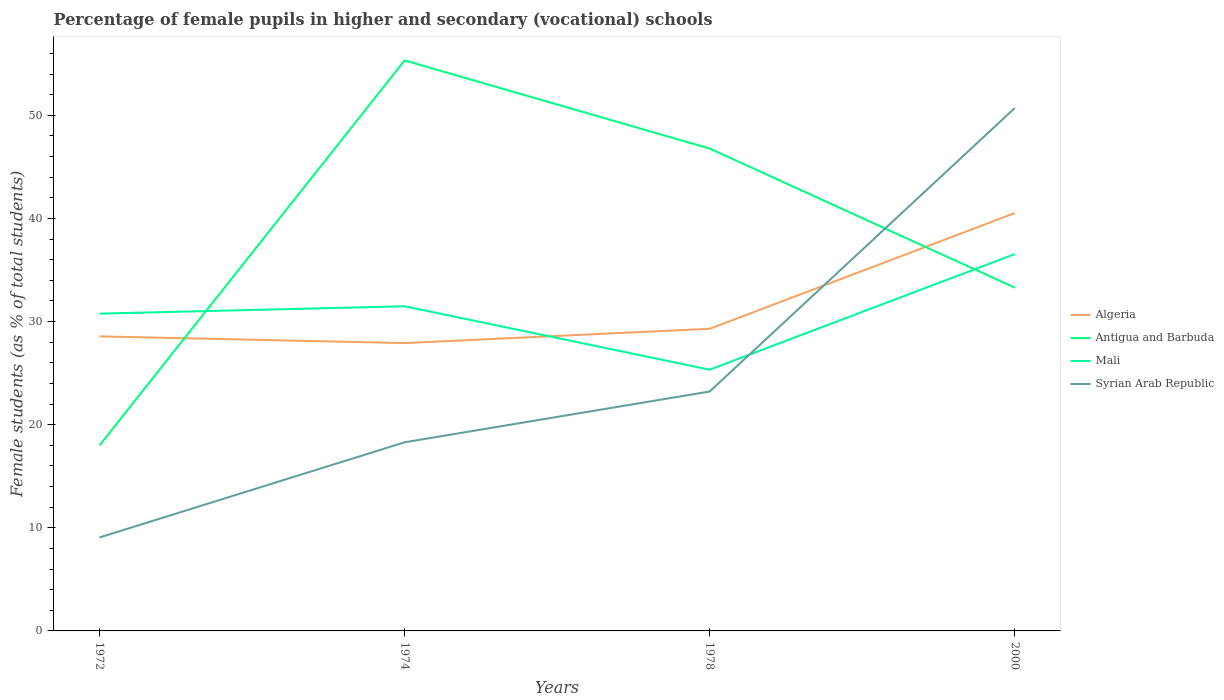Is the number of lines equal to the number of legend labels?
Your answer should be compact. Yes. Across all years, what is the maximum percentage of female pupils in higher and secondary schools in Syrian Arab Republic?
Ensure brevity in your answer.  9.06. In which year was the percentage of female pupils in higher and secondary schools in Syrian Arab Republic maximum?
Offer a very short reply. 1972. What is the total percentage of female pupils in higher and secondary schools in Mali in the graph?
Make the answer very short. -0.71. What is the difference between the highest and the second highest percentage of female pupils in higher and secondary schools in Antigua and Barbuda?
Provide a short and direct response. 37.33. Is the percentage of female pupils in higher and secondary schools in Syrian Arab Republic strictly greater than the percentage of female pupils in higher and secondary schools in Antigua and Barbuda over the years?
Ensure brevity in your answer.  No. How many lines are there?
Ensure brevity in your answer.  4. Where does the legend appear in the graph?
Make the answer very short. Center right. How many legend labels are there?
Make the answer very short. 4. What is the title of the graph?
Ensure brevity in your answer.  Percentage of female pupils in higher and secondary (vocational) schools. What is the label or title of the Y-axis?
Offer a very short reply. Female students (as % of total students). What is the Female students (as % of total students) in Algeria in 1972?
Keep it short and to the point. 28.56. What is the Female students (as % of total students) of Antigua and Barbuda in 1972?
Your answer should be compact. 17.99. What is the Female students (as % of total students) in Mali in 1972?
Your answer should be compact. 30.77. What is the Female students (as % of total students) of Syrian Arab Republic in 1972?
Your answer should be compact. 9.06. What is the Female students (as % of total students) in Algeria in 1974?
Give a very brief answer. 27.91. What is the Female students (as % of total students) in Antigua and Barbuda in 1974?
Your answer should be compact. 55.32. What is the Female students (as % of total students) in Mali in 1974?
Offer a terse response. 31.48. What is the Female students (as % of total students) in Syrian Arab Republic in 1974?
Your answer should be very brief. 18.29. What is the Female students (as % of total students) of Algeria in 1978?
Your answer should be compact. 29.3. What is the Female students (as % of total students) in Antigua and Barbuda in 1978?
Ensure brevity in your answer.  46.77. What is the Female students (as % of total students) of Mali in 1978?
Offer a very short reply. 25.33. What is the Female students (as % of total students) of Syrian Arab Republic in 1978?
Provide a short and direct response. 23.21. What is the Female students (as % of total students) in Algeria in 2000?
Make the answer very short. 40.52. What is the Female students (as % of total students) in Antigua and Barbuda in 2000?
Provide a succinct answer. 33.29. What is the Female students (as % of total students) of Mali in 2000?
Provide a succinct answer. 36.54. What is the Female students (as % of total students) of Syrian Arab Republic in 2000?
Your answer should be very brief. 50.7. Across all years, what is the maximum Female students (as % of total students) of Algeria?
Provide a succinct answer. 40.52. Across all years, what is the maximum Female students (as % of total students) of Antigua and Barbuda?
Your answer should be compact. 55.32. Across all years, what is the maximum Female students (as % of total students) of Mali?
Provide a succinct answer. 36.54. Across all years, what is the maximum Female students (as % of total students) in Syrian Arab Republic?
Provide a succinct answer. 50.7. Across all years, what is the minimum Female students (as % of total students) in Algeria?
Offer a very short reply. 27.91. Across all years, what is the minimum Female students (as % of total students) of Antigua and Barbuda?
Ensure brevity in your answer.  17.99. Across all years, what is the minimum Female students (as % of total students) of Mali?
Provide a succinct answer. 25.33. Across all years, what is the minimum Female students (as % of total students) in Syrian Arab Republic?
Provide a succinct answer. 9.06. What is the total Female students (as % of total students) of Algeria in the graph?
Provide a short and direct response. 126.29. What is the total Female students (as % of total students) in Antigua and Barbuda in the graph?
Provide a short and direct response. 153.37. What is the total Female students (as % of total students) in Mali in the graph?
Make the answer very short. 124.12. What is the total Female students (as % of total students) of Syrian Arab Republic in the graph?
Your answer should be very brief. 101.27. What is the difference between the Female students (as % of total students) in Algeria in 1972 and that in 1974?
Ensure brevity in your answer.  0.65. What is the difference between the Female students (as % of total students) of Antigua and Barbuda in 1972 and that in 1974?
Keep it short and to the point. -37.33. What is the difference between the Female students (as % of total students) in Mali in 1972 and that in 1974?
Your answer should be compact. -0.71. What is the difference between the Female students (as % of total students) in Syrian Arab Republic in 1972 and that in 1974?
Keep it short and to the point. -9.23. What is the difference between the Female students (as % of total students) of Algeria in 1972 and that in 1978?
Your answer should be compact. -0.73. What is the difference between the Female students (as % of total students) of Antigua and Barbuda in 1972 and that in 1978?
Your response must be concise. -28.78. What is the difference between the Female students (as % of total students) in Mali in 1972 and that in 1978?
Offer a very short reply. 5.43. What is the difference between the Female students (as % of total students) in Syrian Arab Republic in 1972 and that in 1978?
Keep it short and to the point. -14.15. What is the difference between the Female students (as % of total students) in Algeria in 1972 and that in 2000?
Keep it short and to the point. -11.96. What is the difference between the Female students (as % of total students) in Antigua and Barbuda in 1972 and that in 2000?
Your answer should be very brief. -15.29. What is the difference between the Female students (as % of total students) in Mali in 1972 and that in 2000?
Provide a succinct answer. -5.77. What is the difference between the Female students (as % of total students) in Syrian Arab Republic in 1972 and that in 2000?
Your answer should be compact. -41.64. What is the difference between the Female students (as % of total students) in Algeria in 1974 and that in 1978?
Provide a short and direct response. -1.38. What is the difference between the Female students (as % of total students) in Antigua and Barbuda in 1974 and that in 1978?
Provide a succinct answer. 8.54. What is the difference between the Female students (as % of total students) of Mali in 1974 and that in 1978?
Your answer should be very brief. 6.15. What is the difference between the Female students (as % of total students) of Syrian Arab Republic in 1974 and that in 1978?
Your answer should be compact. -4.92. What is the difference between the Female students (as % of total students) of Algeria in 1974 and that in 2000?
Provide a succinct answer. -12.61. What is the difference between the Female students (as % of total students) of Antigua and Barbuda in 1974 and that in 2000?
Keep it short and to the point. 22.03. What is the difference between the Female students (as % of total students) of Mali in 1974 and that in 2000?
Give a very brief answer. -5.06. What is the difference between the Female students (as % of total students) in Syrian Arab Republic in 1974 and that in 2000?
Make the answer very short. -32.41. What is the difference between the Female students (as % of total students) in Algeria in 1978 and that in 2000?
Offer a terse response. -11.22. What is the difference between the Female students (as % of total students) of Antigua and Barbuda in 1978 and that in 2000?
Your answer should be very brief. 13.49. What is the difference between the Female students (as % of total students) of Mali in 1978 and that in 2000?
Make the answer very short. -11.21. What is the difference between the Female students (as % of total students) in Syrian Arab Republic in 1978 and that in 2000?
Ensure brevity in your answer.  -27.49. What is the difference between the Female students (as % of total students) in Algeria in 1972 and the Female students (as % of total students) in Antigua and Barbuda in 1974?
Provide a short and direct response. -26.76. What is the difference between the Female students (as % of total students) of Algeria in 1972 and the Female students (as % of total students) of Mali in 1974?
Give a very brief answer. -2.92. What is the difference between the Female students (as % of total students) in Algeria in 1972 and the Female students (as % of total students) in Syrian Arab Republic in 1974?
Make the answer very short. 10.27. What is the difference between the Female students (as % of total students) in Antigua and Barbuda in 1972 and the Female students (as % of total students) in Mali in 1974?
Your answer should be very brief. -13.49. What is the difference between the Female students (as % of total students) of Antigua and Barbuda in 1972 and the Female students (as % of total students) of Syrian Arab Republic in 1974?
Provide a succinct answer. -0.3. What is the difference between the Female students (as % of total students) in Mali in 1972 and the Female students (as % of total students) in Syrian Arab Republic in 1974?
Make the answer very short. 12.48. What is the difference between the Female students (as % of total students) in Algeria in 1972 and the Female students (as % of total students) in Antigua and Barbuda in 1978?
Your answer should be compact. -18.21. What is the difference between the Female students (as % of total students) in Algeria in 1972 and the Female students (as % of total students) in Mali in 1978?
Your answer should be very brief. 3.23. What is the difference between the Female students (as % of total students) of Algeria in 1972 and the Female students (as % of total students) of Syrian Arab Republic in 1978?
Keep it short and to the point. 5.35. What is the difference between the Female students (as % of total students) of Antigua and Barbuda in 1972 and the Female students (as % of total students) of Mali in 1978?
Give a very brief answer. -7.34. What is the difference between the Female students (as % of total students) of Antigua and Barbuda in 1972 and the Female students (as % of total students) of Syrian Arab Republic in 1978?
Offer a terse response. -5.22. What is the difference between the Female students (as % of total students) of Mali in 1972 and the Female students (as % of total students) of Syrian Arab Republic in 1978?
Provide a succinct answer. 7.55. What is the difference between the Female students (as % of total students) of Algeria in 1972 and the Female students (as % of total students) of Antigua and Barbuda in 2000?
Offer a terse response. -4.72. What is the difference between the Female students (as % of total students) of Algeria in 1972 and the Female students (as % of total students) of Mali in 2000?
Make the answer very short. -7.98. What is the difference between the Female students (as % of total students) of Algeria in 1972 and the Female students (as % of total students) of Syrian Arab Republic in 2000?
Keep it short and to the point. -22.14. What is the difference between the Female students (as % of total students) in Antigua and Barbuda in 1972 and the Female students (as % of total students) in Mali in 2000?
Ensure brevity in your answer.  -18.55. What is the difference between the Female students (as % of total students) in Antigua and Barbuda in 1972 and the Female students (as % of total students) in Syrian Arab Republic in 2000?
Give a very brief answer. -32.71. What is the difference between the Female students (as % of total students) of Mali in 1972 and the Female students (as % of total students) of Syrian Arab Republic in 2000?
Your answer should be very brief. -19.93. What is the difference between the Female students (as % of total students) in Algeria in 1974 and the Female students (as % of total students) in Antigua and Barbuda in 1978?
Your response must be concise. -18.86. What is the difference between the Female students (as % of total students) of Algeria in 1974 and the Female students (as % of total students) of Mali in 1978?
Provide a short and direct response. 2.58. What is the difference between the Female students (as % of total students) of Algeria in 1974 and the Female students (as % of total students) of Syrian Arab Republic in 1978?
Provide a short and direct response. 4.7. What is the difference between the Female students (as % of total students) of Antigua and Barbuda in 1974 and the Female students (as % of total students) of Mali in 1978?
Keep it short and to the point. 29.99. What is the difference between the Female students (as % of total students) in Antigua and Barbuda in 1974 and the Female students (as % of total students) in Syrian Arab Republic in 1978?
Make the answer very short. 32.1. What is the difference between the Female students (as % of total students) of Mali in 1974 and the Female students (as % of total students) of Syrian Arab Republic in 1978?
Your answer should be compact. 8.27. What is the difference between the Female students (as % of total students) of Algeria in 1974 and the Female students (as % of total students) of Antigua and Barbuda in 2000?
Keep it short and to the point. -5.37. What is the difference between the Female students (as % of total students) in Algeria in 1974 and the Female students (as % of total students) in Mali in 2000?
Keep it short and to the point. -8.63. What is the difference between the Female students (as % of total students) in Algeria in 1974 and the Female students (as % of total students) in Syrian Arab Republic in 2000?
Provide a short and direct response. -22.79. What is the difference between the Female students (as % of total students) in Antigua and Barbuda in 1974 and the Female students (as % of total students) in Mali in 2000?
Your answer should be very brief. 18.78. What is the difference between the Female students (as % of total students) of Antigua and Barbuda in 1974 and the Female students (as % of total students) of Syrian Arab Republic in 2000?
Give a very brief answer. 4.62. What is the difference between the Female students (as % of total students) of Mali in 1974 and the Female students (as % of total students) of Syrian Arab Republic in 2000?
Your answer should be very brief. -19.22. What is the difference between the Female students (as % of total students) of Algeria in 1978 and the Female students (as % of total students) of Antigua and Barbuda in 2000?
Your answer should be compact. -3.99. What is the difference between the Female students (as % of total students) of Algeria in 1978 and the Female students (as % of total students) of Mali in 2000?
Your answer should be very brief. -7.24. What is the difference between the Female students (as % of total students) of Algeria in 1978 and the Female students (as % of total students) of Syrian Arab Republic in 2000?
Give a very brief answer. -21.4. What is the difference between the Female students (as % of total students) in Antigua and Barbuda in 1978 and the Female students (as % of total students) in Mali in 2000?
Give a very brief answer. 10.23. What is the difference between the Female students (as % of total students) in Antigua and Barbuda in 1978 and the Female students (as % of total students) in Syrian Arab Republic in 2000?
Keep it short and to the point. -3.93. What is the difference between the Female students (as % of total students) of Mali in 1978 and the Female students (as % of total students) of Syrian Arab Republic in 2000?
Provide a succinct answer. -25.37. What is the average Female students (as % of total students) of Algeria per year?
Offer a terse response. 31.57. What is the average Female students (as % of total students) in Antigua and Barbuda per year?
Give a very brief answer. 38.34. What is the average Female students (as % of total students) of Mali per year?
Keep it short and to the point. 31.03. What is the average Female students (as % of total students) in Syrian Arab Republic per year?
Offer a terse response. 25.32. In the year 1972, what is the difference between the Female students (as % of total students) in Algeria and Female students (as % of total students) in Antigua and Barbuda?
Offer a very short reply. 10.57. In the year 1972, what is the difference between the Female students (as % of total students) in Algeria and Female students (as % of total students) in Mali?
Give a very brief answer. -2.2. In the year 1972, what is the difference between the Female students (as % of total students) in Algeria and Female students (as % of total students) in Syrian Arab Republic?
Make the answer very short. 19.5. In the year 1972, what is the difference between the Female students (as % of total students) of Antigua and Barbuda and Female students (as % of total students) of Mali?
Your response must be concise. -12.77. In the year 1972, what is the difference between the Female students (as % of total students) of Antigua and Barbuda and Female students (as % of total students) of Syrian Arab Republic?
Ensure brevity in your answer.  8.93. In the year 1972, what is the difference between the Female students (as % of total students) in Mali and Female students (as % of total students) in Syrian Arab Republic?
Offer a terse response. 21.7. In the year 1974, what is the difference between the Female students (as % of total students) of Algeria and Female students (as % of total students) of Antigua and Barbuda?
Ensure brevity in your answer.  -27.41. In the year 1974, what is the difference between the Female students (as % of total students) of Algeria and Female students (as % of total students) of Mali?
Your answer should be very brief. -3.57. In the year 1974, what is the difference between the Female students (as % of total students) of Algeria and Female students (as % of total students) of Syrian Arab Republic?
Ensure brevity in your answer.  9.62. In the year 1974, what is the difference between the Female students (as % of total students) of Antigua and Barbuda and Female students (as % of total students) of Mali?
Your response must be concise. 23.84. In the year 1974, what is the difference between the Female students (as % of total students) of Antigua and Barbuda and Female students (as % of total students) of Syrian Arab Republic?
Offer a terse response. 37.03. In the year 1974, what is the difference between the Female students (as % of total students) in Mali and Female students (as % of total students) in Syrian Arab Republic?
Offer a very short reply. 13.19. In the year 1978, what is the difference between the Female students (as % of total students) in Algeria and Female students (as % of total students) in Antigua and Barbuda?
Your answer should be very brief. -17.48. In the year 1978, what is the difference between the Female students (as % of total students) of Algeria and Female students (as % of total students) of Mali?
Keep it short and to the point. 3.97. In the year 1978, what is the difference between the Female students (as % of total students) of Algeria and Female students (as % of total students) of Syrian Arab Republic?
Make the answer very short. 6.08. In the year 1978, what is the difference between the Female students (as % of total students) of Antigua and Barbuda and Female students (as % of total students) of Mali?
Make the answer very short. 21.44. In the year 1978, what is the difference between the Female students (as % of total students) in Antigua and Barbuda and Female students (as % of total students) in Syrian Arab Republic?
Offer a very short reply. 23.56. In the year 1978, what is the difference between the Female students (as % of total students) of Mali and Female students (as % of total students) of Syrian Arab Republic?
Provide a succinct answer. 2.12. In the year 2000, what is the difference between the Female students (as % of total students) of Algeria and Female students (as % of total students) of Antigua and Barbuda?
Your response must be concise. 7.23. In the year 2000, what is the difference between the Female students (as % of total students) of Algeria and Female students (as % of total students) of Mali?
Offer a terse response. 3.98. In the year 2000, what is the difference between the Female students (as % of total students) of Algeria and Female students (as % of total students) of Syrian Arab Republic?
Ensure brevity in your answer.  -10.18. In the year 2000, what is the difference between the Female students (as % of total students) of Antigua and Barbuda and Female students (as % of total students) of Mali?
Ensure brevity in your answer.  -3.26. In the year 2000, what is the difference between the Female students (as % of total students) of Antigua and Barbuda and Female students (as % of total students) of Syrian Arab Republic?
Your answer should be very brief. -17.41. In the year 2000, what is the difference between the Female students (as % of total students) of Mali and Female students (as % of total students) of Syrian Arab Republic?
Offer a very short reply. -14.16. What is the ratio of the Female students (as % of total students) of Algeria in 1972 to that in 1974?
Make the answer very short. 1.02. What is the ratio of the Female students (as % of total students) of Antigua and Barbuda in 1972 to that in 1974?
Your answer should be compact. 0.33. What is the ratio of the Female students (as % of total students) in Mali in 1972 to that in 1974?
Offer a terse response. 0.98. What is the ratio of the Female students (as % of total students) in Syrian Arab Republic in 1972 to that in 1974?
Offer a terse response. 0.5. What is the ratio of the Female students (as % of total students) of Algeria in 1972 to that in 1978?
Provide a succinct answer. 0.97. What is the ratio of the Female students (as % of total students) of Antigua and Barbuda in 1972 to that in 1978?
Your answer should be compact. 0.38. What is the ratio of the Female students (as % of total students) of Mali in 1972 to that in 1978?
Make the answer very short. 1.21. What is the ratio of the Female students (as % of total students) of Syrian Arab Republic in 1972 to that in 1978?
Make the answer very short. 0.39. What is the ratio of the Female students (as % of total students) of Algeria in 1972 to that in 2000?
Offer a very short reply. 0.7. What is the ratio of the Female students (as % of total students) of Antigua and Barbuda in 1972 to that in 2000?
Your answer should be compact. 0.54. What is the ratio of the Female students (as % of total students) in Mali in 1972 to that in 2000?
Ensure brevity in your answer.  0.84. What is the ratio of the Female students (as % of total students) of Syrian Arab Republic in 1972 to that in 2000?
Your answer should be very brief. 0.18. What is the ratio of the Female students (as % of total students) of Algeria in 1974 to that in 1978?
Your response must be concise. 0.95. What is the ratio of the Female students (as % of total students) of Antigua and Barbuda in 1974 to that in 1978?
Your answer should be compact. 1.18. What is the ratio of the Female students (as % of total students) in Mali in 1974 to that in 1978?
Your answer should be compact. 1.24. What is the ratio of the Female students (as % of total students) of Syrian Arab Republic in 1974 to that in 1978?
Offer a terse response. 0.79. What is the ratio of the Female students (as % of total students) in Algeria in 1974 to that in 2000?
Your answer should be compact. 0.69. What is the ratio of the Female students (as % of total students) of Antigua and Barbuda in 1974 to that in 2000?
Give a very brief answer. 1.66. What is the ratio of the Female students (as % of total students) of Mali in 1974 to that in 2000?
Provide a short and direct response. 0.86. What is the ratio of the Female students (as % of total students) in Syrian Arab Republic in 1974 to that in 2000?
Offer a terse response. 0.36. What is the ratio of the Female students (as % of total students) in Algeria in 1978 to that in 2000?
Your answer should be compact. 0.72. What is the ratio of the Female students (as % of total students) of Antigua and Barbuda in 1978 to that in 2000?
Provide a short and direct response. 1.41. What is the ratio of the Female students (as % of total students) of Mali in 1978 to that in 2000?
Keep it short and to the point. 0.69. What is the ratio of the Female students (as % of total students) of Syrian Arab Republic in 1978 to that in 2000?
Provide a short and direct response. 0.46. What is the difference between the highest and the second highest Female students (as % of total students) of Algeria?
Your response must be concise. 11.22. What is the difference between the highest and the second highest Female students (as % of total students) in Antigua and Barbuda?
Give a very brief answer. 8.54. What is the difference between the highest and the second highest Female students (as % of total students) in Mali?
Provide a short and direct response. 5.06. What is the difference between the highest and the second highest Female students (as % of total students) in Syrian Arab Republic?
Offer a very short reply. 27.49. What is the difference between the highest and the lowest Female students (as % of total students) in Algeria?
Make the answer very short. 12.61. What is the difference between the highest and the lowest Female students (as % of total students) in Antigua and Barbuda?
Give a very brief answer. 37.33. What is the difference between the highest and the lowest Female students (as % of total students) of Mali?
Provide a succinct answer. 11.21. What is the difference between the highest and the lowest Female students (as % of total students) in Syrian Arab Republic?
Ensure brevity in your answer.  41.64. 